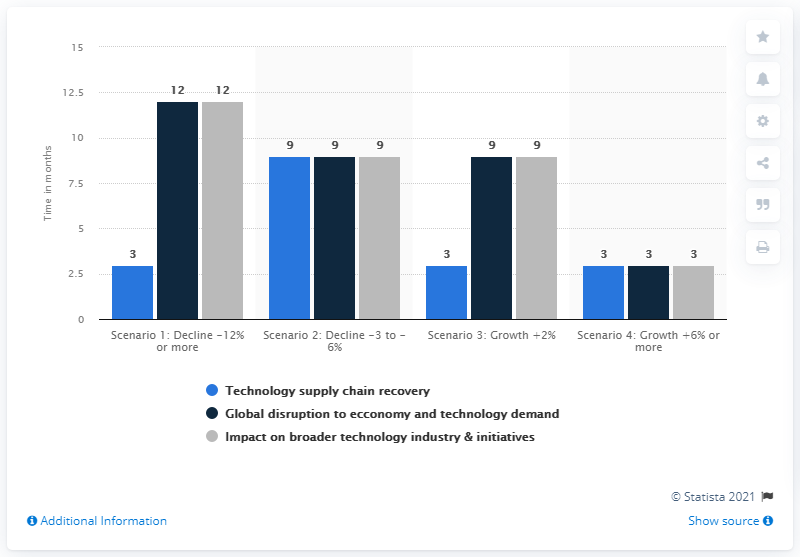Highlight a few significant elements in this photo. The sum of the combined values for Scenario 2 is 27. The worst-case scenario for the decline of global semiconductor industry revenues would be a 12% decrease. The lowest value for Scenario 1 is 3. 